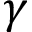<formula> <loc_0><loc_0><loc_500><loc_500>\gamma</formula> 